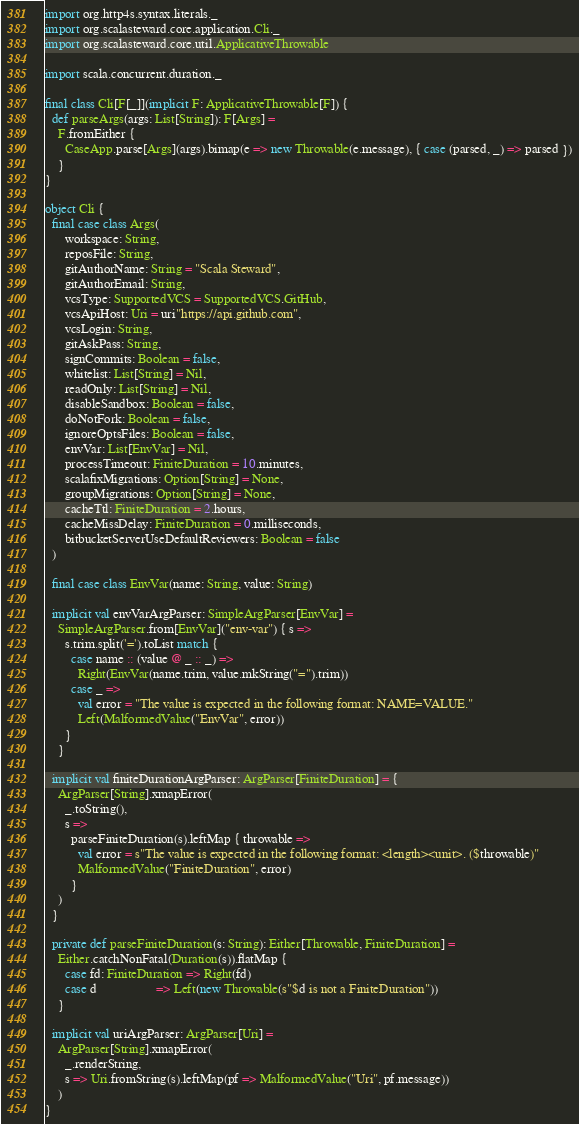<code> <loc_0><loc_0><loc_500><loc_500><_Scala_>import org.http4s.syntax.literals._
import org.scalasteward.core.application.Cli._
import org.scalasteward.core.util.ApplicativeThrowable

import scala.concurrent.duration._

final class Cli[F[_]](implicit F: ApplicativeThrowable[F]) {
  def parseArgs(args: List[String]): F[Args] =
    F.fromEither {
      CaseApp.parse[Args](args).bimap(e => new Throwable(e.message), { case (parsed, _) => parsed })
    }
}

object Cli {
  final case class Args(
      workspace: String,
      reposFile: String,
      gitAuthorName: String = "Scala Steward",
      gitAuthorEmail: String,
      vcsType: SupportedVCS = SupportedVCS.GitHub,
      vcsApiHost: Uri = uri"https://api.github.com",
      vcsLogin: String,
      gitAskPass: String,
      signCommits: Boolean = false,
      whitelist: List[String] = Nil,
      readOnly: List[String] = Nil,
      disableSandbox: Boolean = false,
      doNotFork: Boolean = false,
      ignoreOptsFiles: Boolean = false,
      envVar: List[EnvVar] = Nil,
      processTimeout: FiniteDuration = 10.minutes,
      scalafixMigrations: Option[String] = None,
      groupMigrations: Option[String] = None,
      cacheTtl: FiniteDuration = 2.hours,
      cacheMissDelay: FiniteDuration = 0.milliseconds,
      bitbucketServerUseDefaultReviewers: Boolean = false
  )

  final case class EnvVar(name: String, value: String)

  implicit val envVarArgParser: SimpleArgParser[EnvVar] =
    SimpleArgParser.from[EnvVar]("env-var") { s =>
      s.trim.split('=').toList match {
        case name :: (value @ _ :: _) =>
          Right(EnvVar(name.trim, value.mkString("=").trim))
        case _ =>
          val error = "The value is expected in the following format: NAME=VALUE."
          Left(MalformedValue("EnvVar", error))
      }
    }

  implicit val finiteDurationArgParser: ArgParser[FiniteDuration] = {
    ArgParser[String].xmapError(
      _.toString(),
      s =>
        parseFiniteDuration(s).leftMap { throwable =>
          val error = s"The value is expected in the following format: <length><unit>. ($throwable)"
          MalformedValue("FiniteDuration", error)
        }
    )
  }

  private def parseFiniteDuration(s: String): Either[Throwable, FiniteDuration] =
    Either.catchNonFatal(Duration(s)).flatMap {
      case fd: FiniteDuration => Right(fd)
      case d                  => Left(new Throwable(s"$d is not a FiniteDuration"))
    }

  implicit val uriArgParser: ArgParser[Uri] =
    ArgParser[String].xmapError(
      _.renderString,
      s => Uri.fromString(s).leftMap(pf => MalformedValue("Uri", pf.message))
    )
}
</code> 